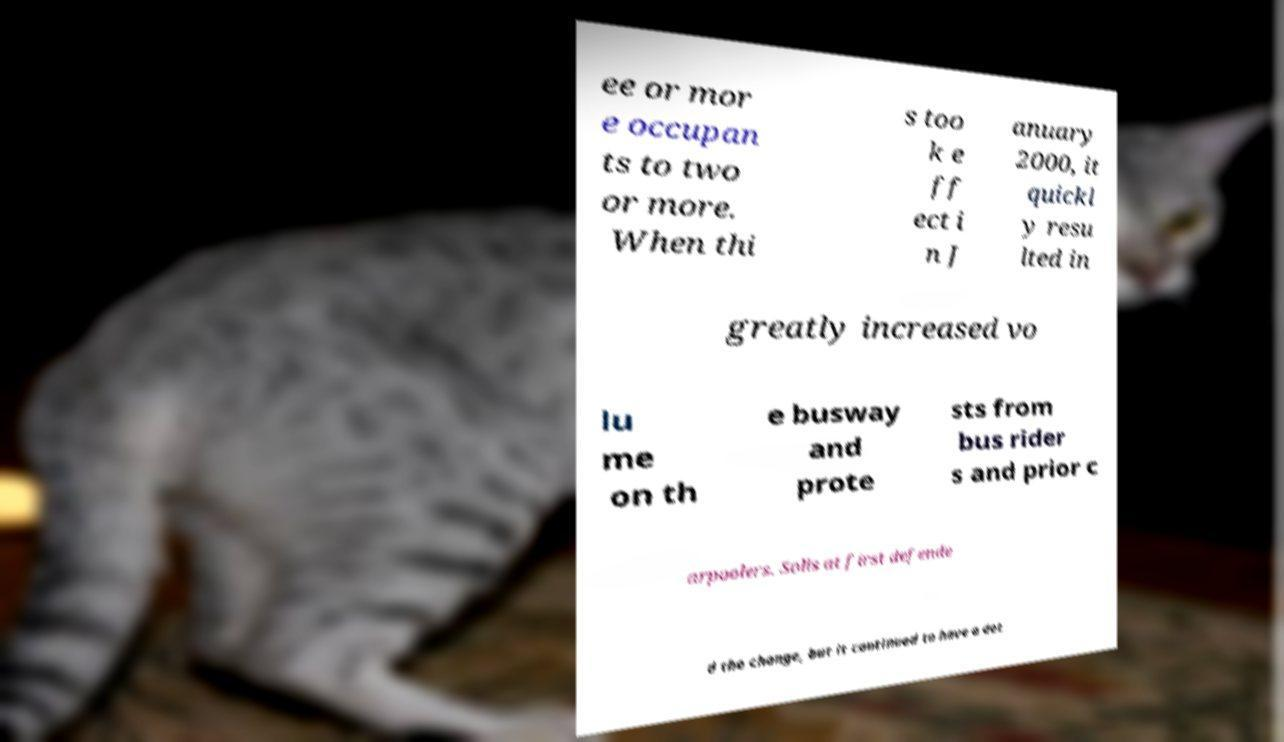Can you read and provide the text displayed in the image?This photo seems to have some interesting text. Can you extract and type it out for me? ee or mor e occupan ts to two or more. When thi s too k e ff ect i n J anuary 2000, it quickl y resu lted in greatly increased vo lu me on th e busway and prote sts from bus rider s and prior c arpoolers. Solis at first defende d the change, but it continued to have a det 